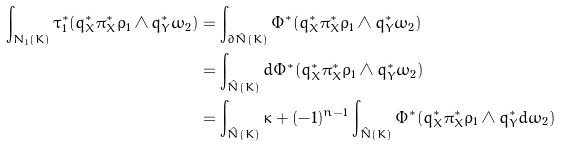<formula> <loc_0><loc_0><loc_500><loc_500>\int _ { N _ { 1 } ( K ) } \tau _ { 1 } ^ { * } ( q _ { X } ^ { * } \pi _ { X } ^ { * } \rho _ { 1 } \wedge q _ { Y } ^ { * } \omega _ { 2 } ) & = \int _ { \partial \hat { N } ( K ) } \Phi ^ { * } ( q _ { X } ^ { * } \pi _ { X } ^ { * } \rho _ { 1 } \wedge q _ { Y } ^ { * } \omega _ { 2 } ) \\ & = \int _ { \hat { N } ( K ) } d \Phi ^ { * } ( q _ { X } ^ { * } \pi _ { X } ^ { * } \rho _ { 1 } \wedge q _ { Y } ^ { * } \omega _ { 2 } ) \\ & = \int _ { \hat { N } ( K ) } \kappa + ( - 1 ) ^ { n - 1 } \int _ { \hat { N } ( K ) } \Phi ^ { * } ( q _ { X } ^ { * } \pi _ { X } ^ { * } \rho _ { 1 } \wedge q _ { Y } ^ { * } d \omega _ { 2 } )</formula> 